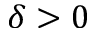Convert formula to latex. <formula><loc_0><loc_0><loc_500><loc_500>\delta > 0</formula> 